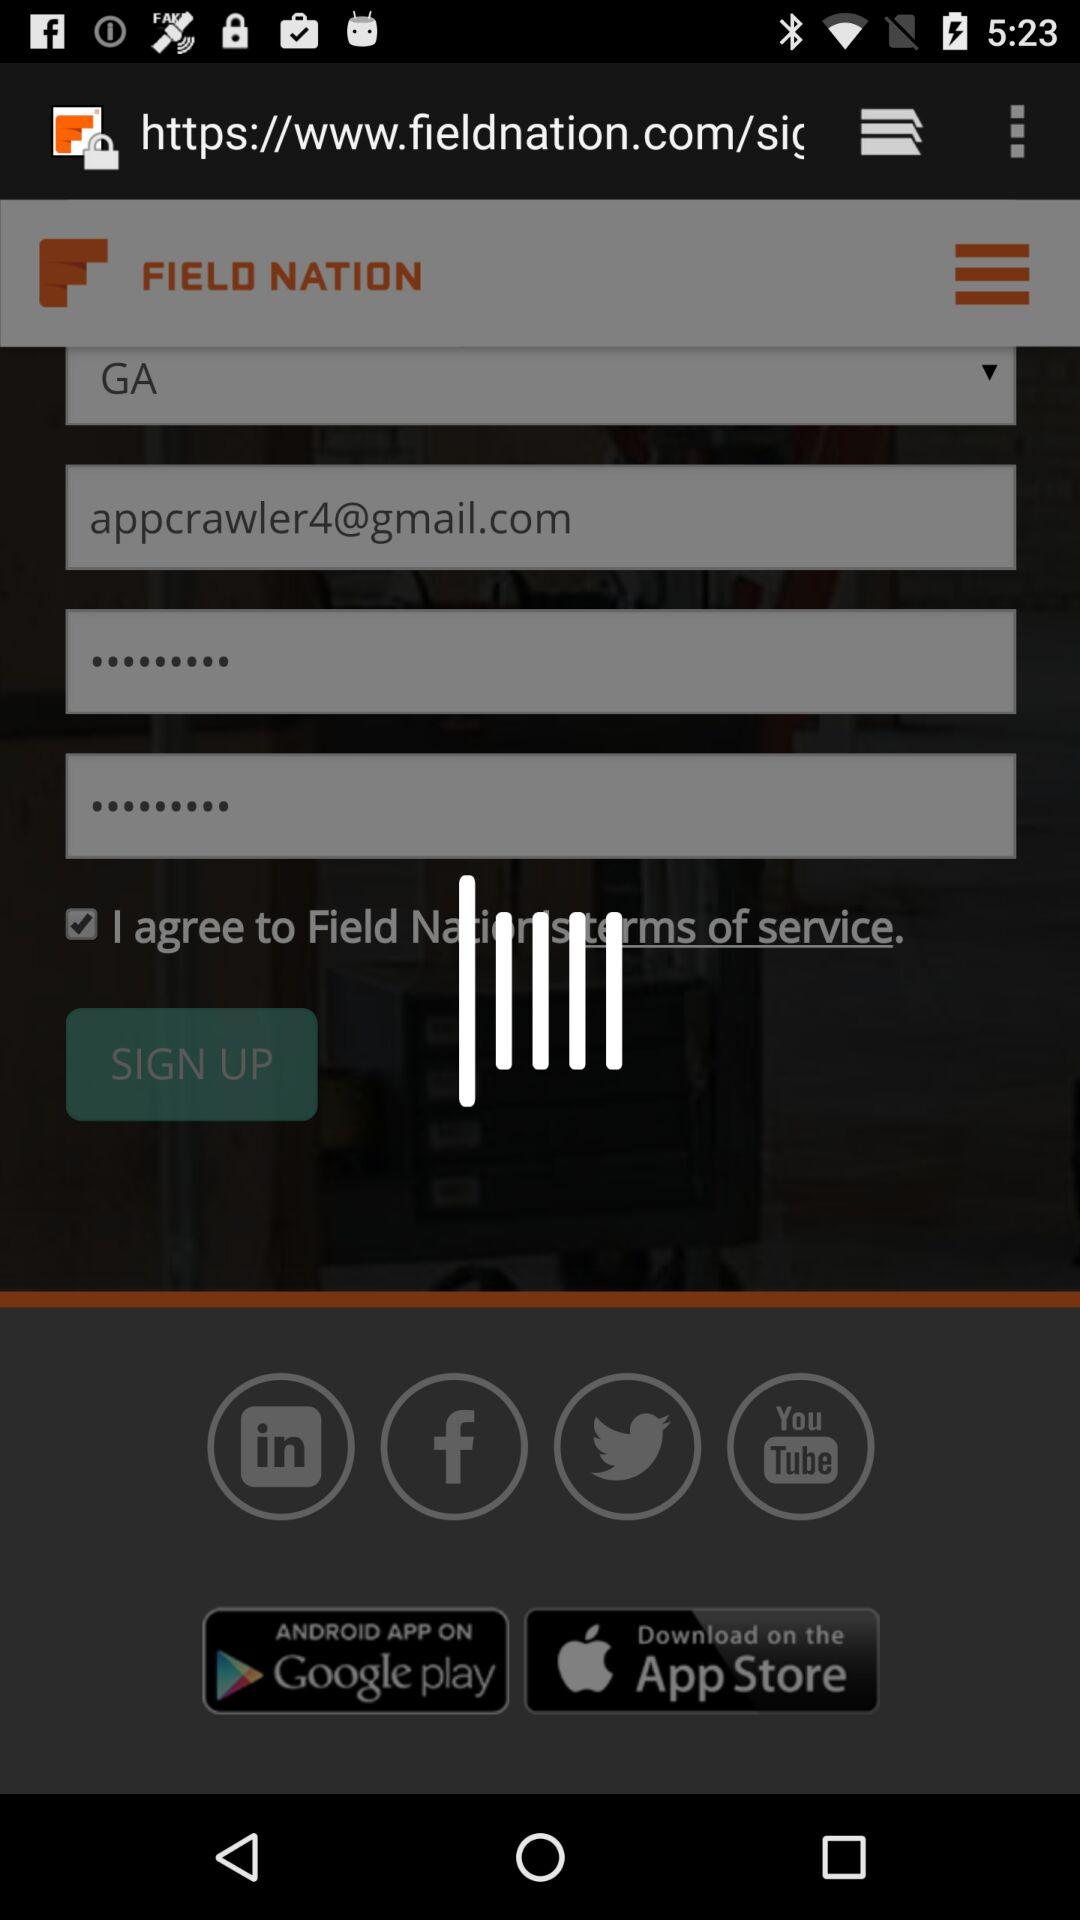What is the status of the option that includes acceptance to the “terms of service”? The status is "on". 